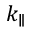Convert formula to latex. <formula><loc_0><loc_0><loc_500><loc_500>k _ { \| }</formula> 